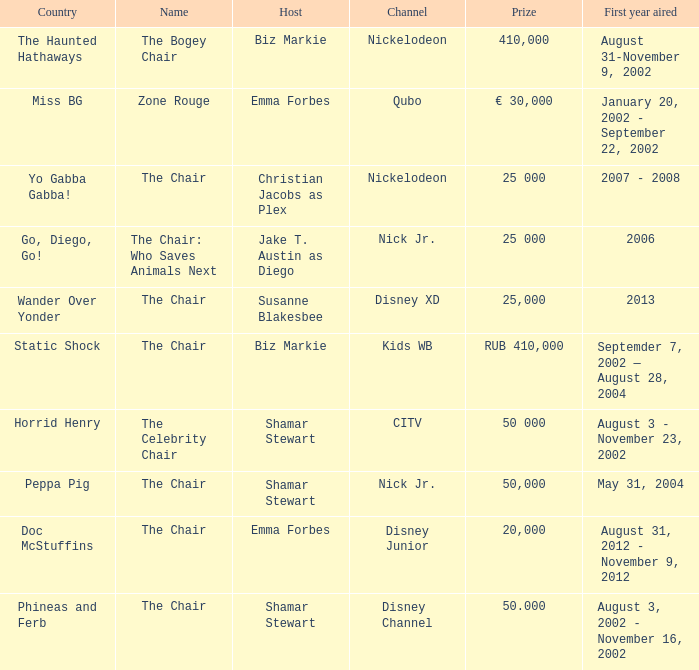What was the host of Horrid Henry? Shamar Stewart. 